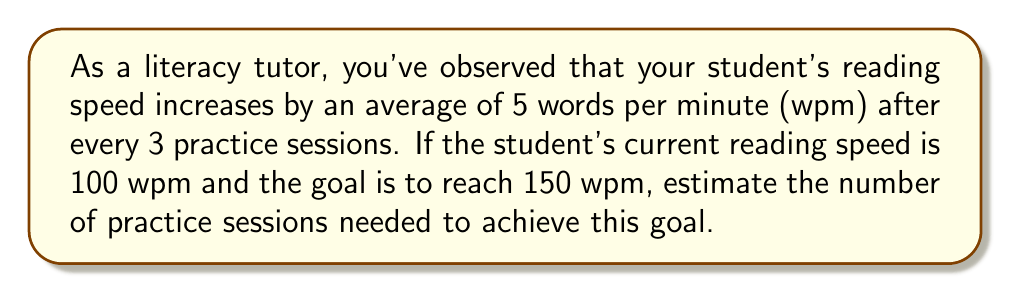Provide a solution to this math problem. Let's approach this step-by-step:

1) First, calculate the total increase in reading speed needed:
   $150 \text{ wpm} - 100 \text{ wpm} = 50 \text{ wpm}$

2) We know that the speed increases by 5 wpm every 3 sessions. Let's express this as a rate:
   $\frac{5 \text{ wpm}}{3 \text{ sessions}}$

3) To find the number of sessions, we can set up the following equation:
   $$ \frac{5 \text{ wpm}}{3 \text{ sessions}} \times x \text{ sessions} = 50 \text{ wpm} $$

4) Solve for $x$:
   $$ x = \frac{50 \text{ wpm} \times 3 \text{ sessions}}{5 \text{ wpm}} = 30 \text{ sessions} $$

Therefore, it would take approximately 30 practice sessions to reach the goal reading speed.
Answer: 30 sessions 